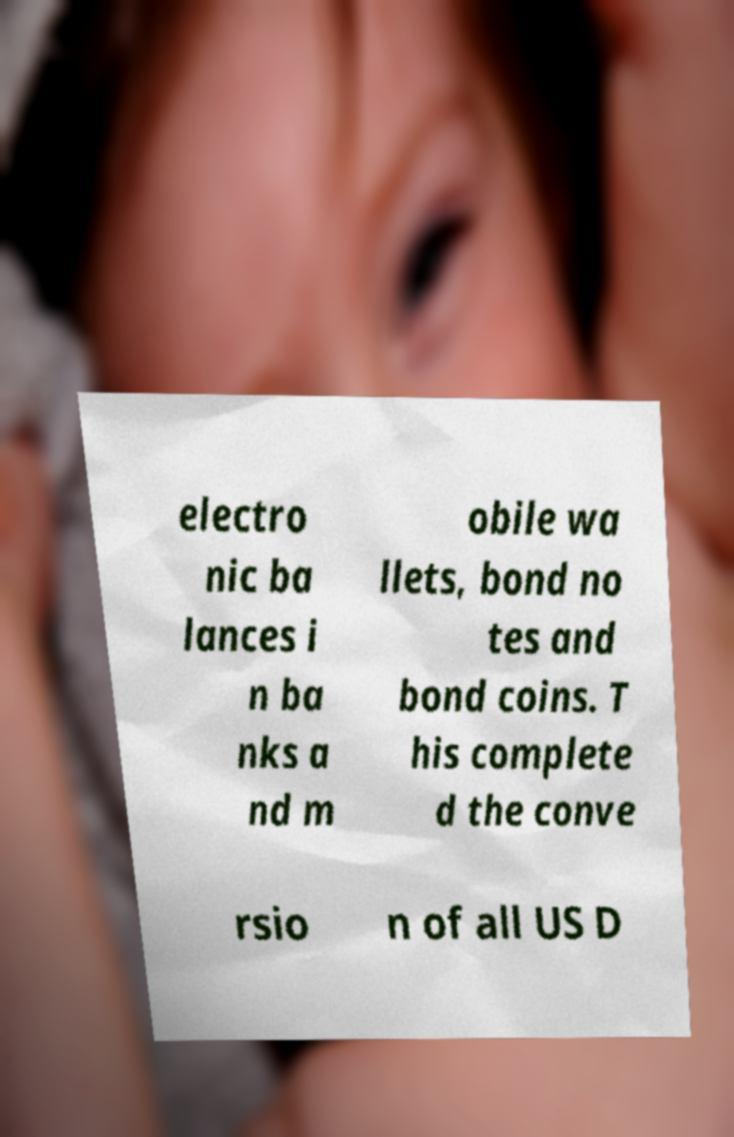There's text embedded in this image that I need extracted. Can you transcribe it verbatim? electro nic ba lances i n ba nks a nd m obile wa llets, bond no tes and bond coins. T his complete d the conve rsio n of all US D 